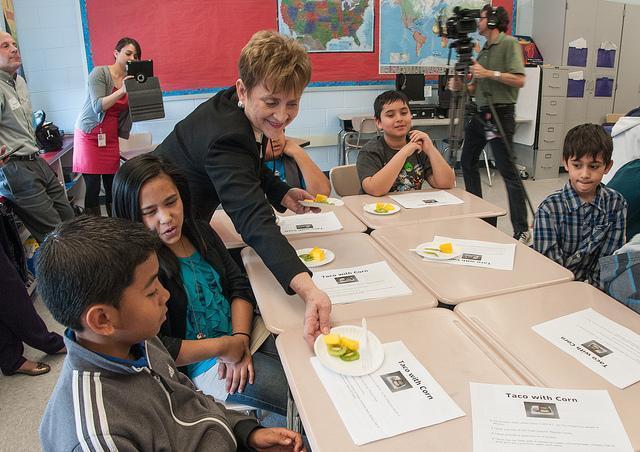How many books can be seen?
Give a very brief answer. 2. How many people are in the picture?
Give a very brief answer. 10. 